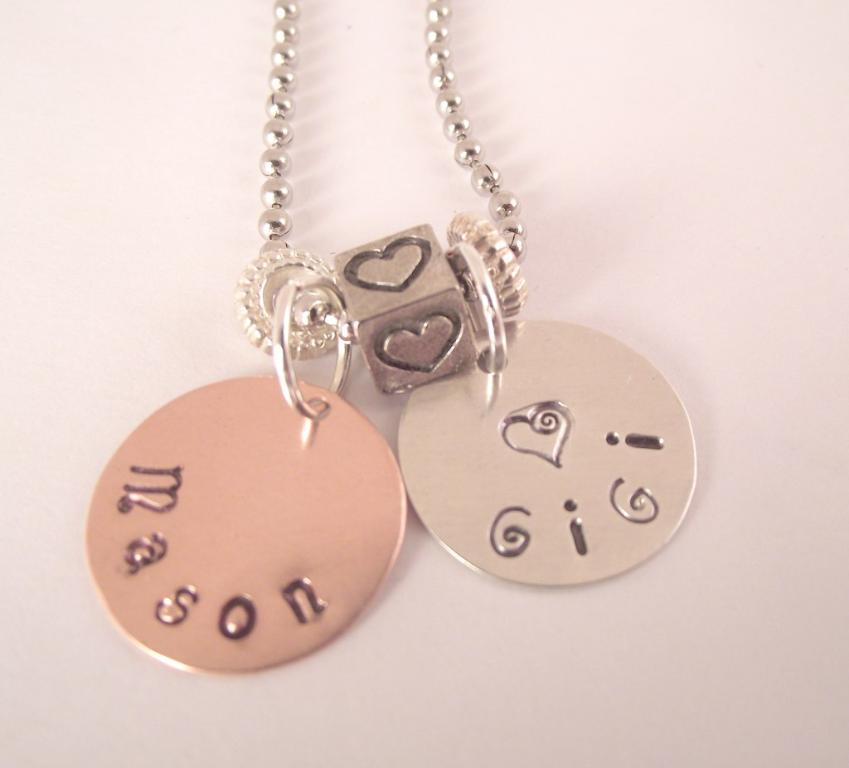What is the main object in the image? There is a locket in the image. What type of bean is depicted in the caption of the image? There is no bean or caption present in the image; it only features a locket. 